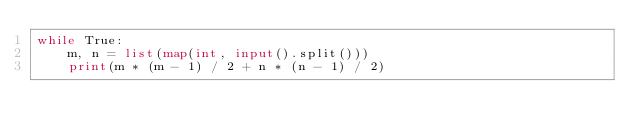Convert code to text. <code><loc_0><loc_0><loc_500><loc_500><_Python_>while True:
    m, n = list(map(int, input().split()))
    print(m * (m - 1) / 2 + n * (n - 1) / 2)
</code> 